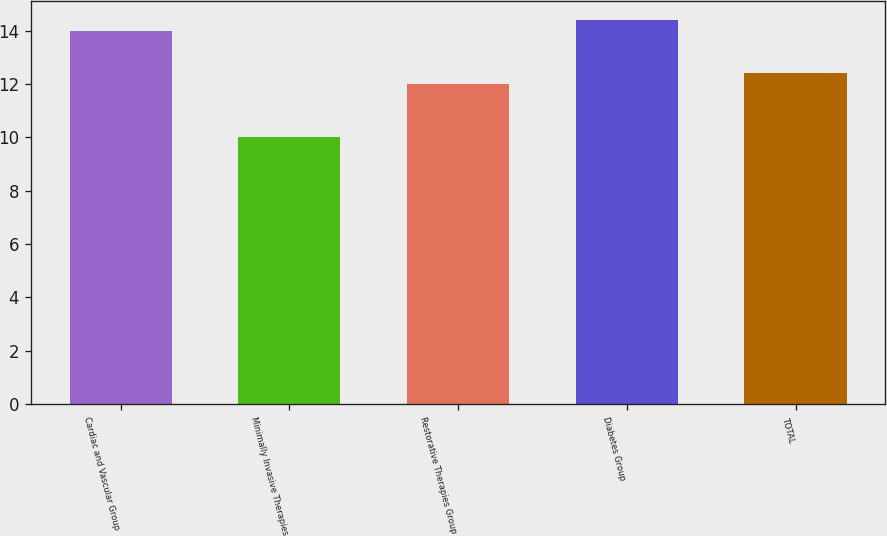Convert chart to OTSL. <chart><loc_0><loc_0><loc_500><loc_500><bar_chart><fcel>Cardiac and Vascular Group<fcel>Minimally Invasive Therapies<fcel>Restorative Therapies Group<fcel>Diabetes Group<fcel>TOTAL<nl><fcel>14<fcel>10<fcel>12<fcel>14.4<fcel>12.4<nl></chart> 